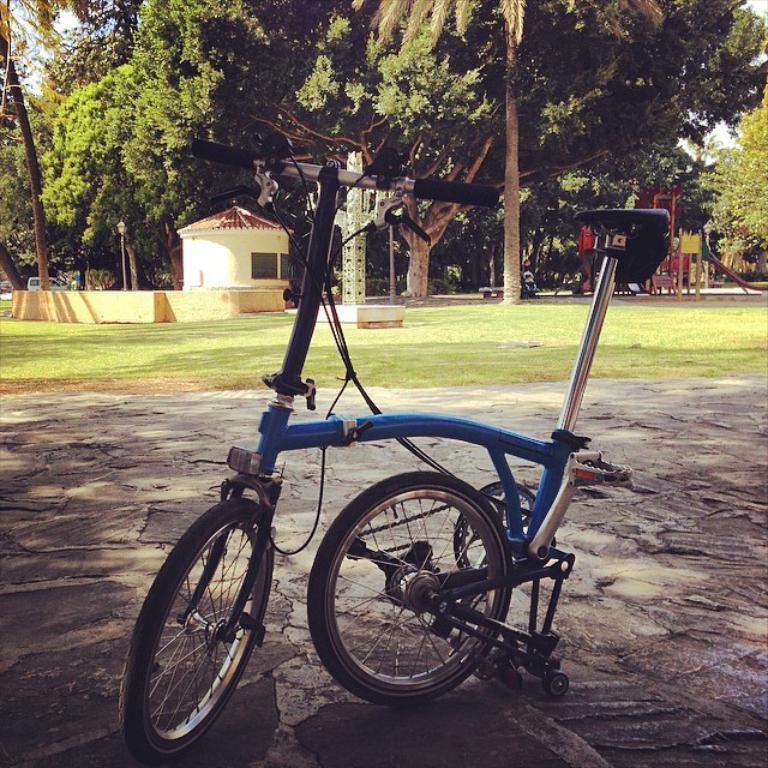Describe this image in one or two sentences. In this image we can see bicycle on the road. In the background there are sky, trees, motor vehicles, sheds and a person. 